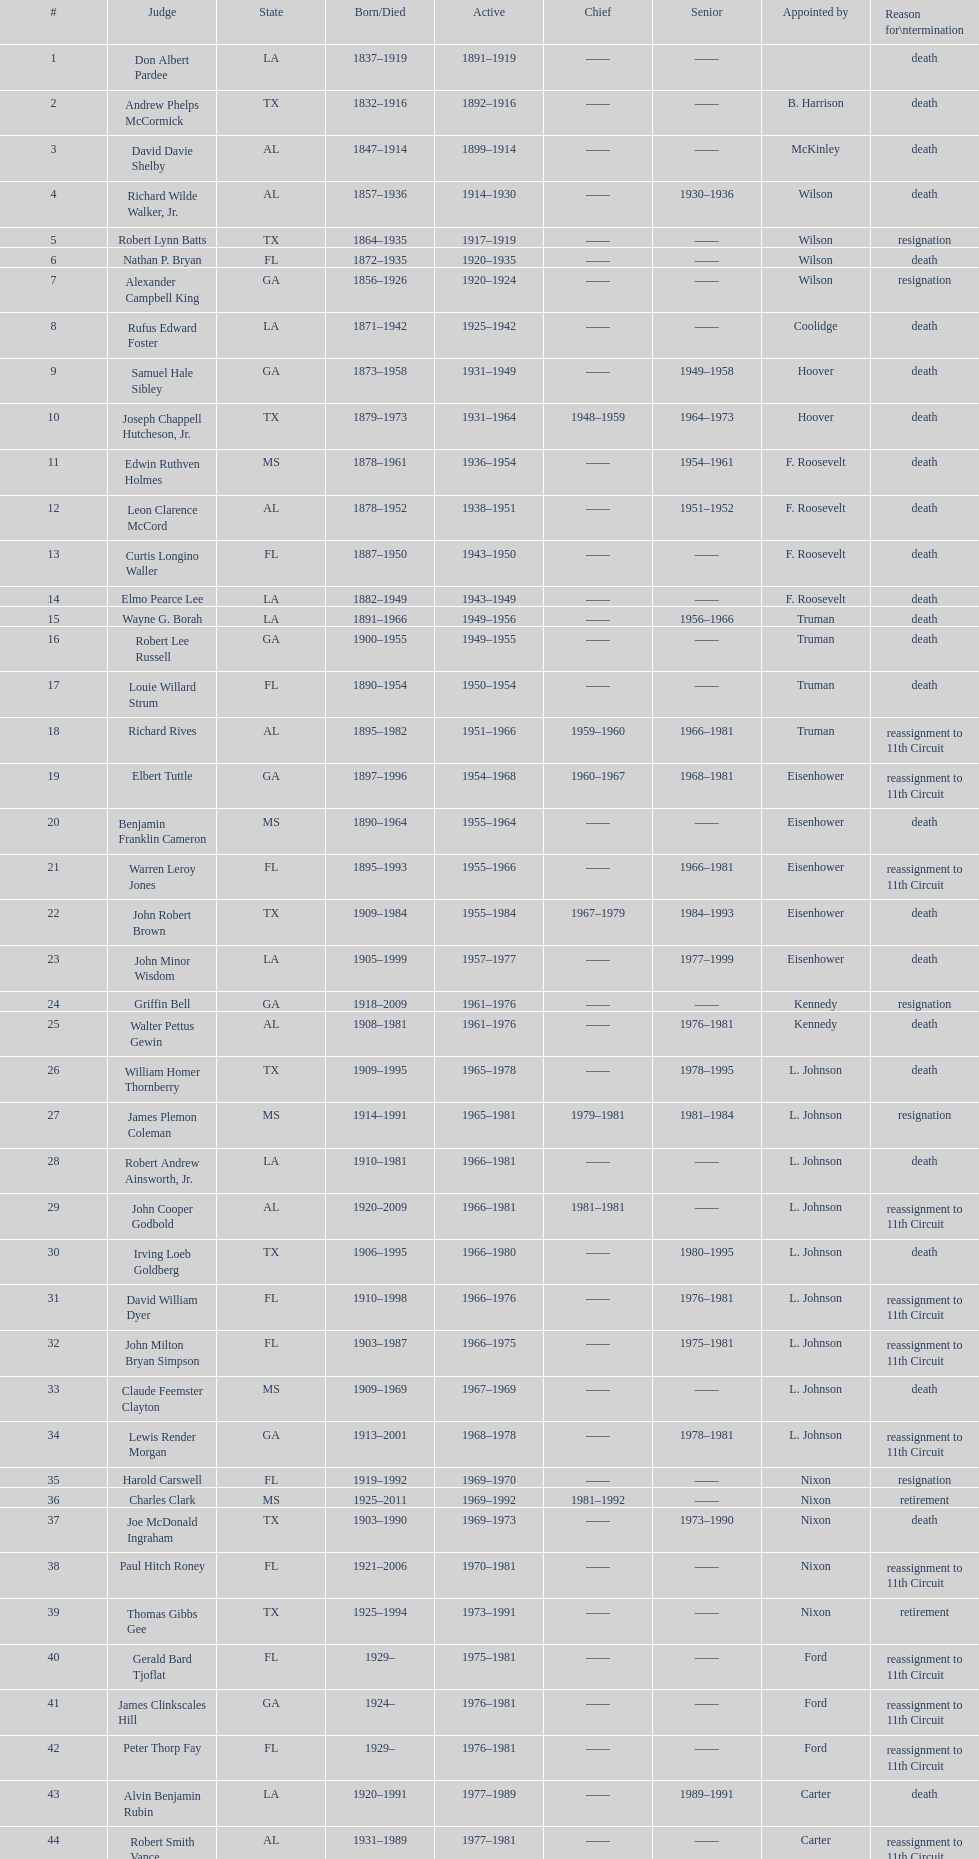After alexander campbell king, which judge resigned next? Griffin Bell. Would you mind parsing the complete table? {'header': ['#', 'Judge', 'State', 'Born/Died', 'Active', 'Chief', 'Senior', 'Appointed by', 'Reason for\\ntermination'], 'rows': [['1', 'Don Albert Pardee', 'LA', '1837–1919', '1891–1919', '——', '——', '', 'death'], ['2', 'Andrew Phelps McCormick', 'TX', '1832–1916', '1892–1916', '——', '——', 'B. Harrison', 'death'], ['3', 'David Davie Shelby', 'AL', '1847–1914', '1899–1914', '——', '——', 'McKinley', 'death'], ['4', 'Richard Wilde Walker, Jr.', 'AL', '1857–1936', '1914–1930', '——', '1930–1936', 'Wilson', 'death'], ['5', 'Robert Lynn Batts', 'TX', '1864–1935', '1917–1919', '——', '——', 'Wilson', 'resignation'], ['6', 'Nathan P. Bryan', 'FL', '1872–1935', '1920–1935', '——', '——', 'Wilson', 'death'], ['7', 'Alexander Campbell King', 'GA', '1856–1926', '1920–1924', '——', '——', 'Wilson', 'resignation'], ['8', 'Rufus Edward Foster', 'LA', '1871–1942', '1925–1942', '——', '——', 'Coolidge', 'death'], ['9', 'Samuel Hale Sibley', 'GA', '1873–1958', '1931–1949', '——', '1949–1958', 'Hoover', 'death'], ['10', 'Joseph Chappell Hutcheson, Jr.', 'TX', '1879–1973', '1931–1964', '1948–1959', '1964–1973', 'Hoover', 'death'], ['11', 'Edwin Ruthven Holmes', 'MS', '1878–1961', '1936–1954', '——', '1954–1961', 'F. Roosevelt', 'death'], ['12', 'Leon Clarence McCord', 'AL', '1878–1952', '1938–1951', '——', '1951–1952', 'F. Roosevelt', 'death'], ['13', 'Curtis Longino Waller', 'FL', '1887–1950', '1943–1950', '——', '——', 'F. Roosevelt', 'death'], ['14', 'Elmo Pearce Lee', 'LA', '1882–1949', '1943–1949', '——', '——', 'F. Roosevelt', 'death'], ['15', 'Wayne G. Borah', 'LA', '1891–1966', '1949–1956', '——', '1956–1966', 'Truman', 'death'], ['16', 'Robert Lee Russell', 'GA', '1900–1955', '1949–1955', '——', '——', 'Truman', 'death'], ['17', 'Louie Willard Strum', 'FL', '1890–1954', '1950–1954', '——', '——', 'Truman', 'death'], ['18', 'Richard Rives', 'AL', '1895–1982', '1951–1966', '1959–1960', '1966–1981', 'Truman', 'reassignment to 11th Circuit'], ['19', 'Elbert Tuttle', 'GA', '1897–1996', '1954–1968', '1960–1967', '1968–1981', 'Eisenhower', 'reassignment to 11th Circuit'], ['20', 'Benjamin Franklin Cameron', 'MS', '1890–1964', '1955–1964', '——', '——', 'Eisenhower', 'death'], ['21', 'Warren Leroy Jones', 'FL', '1895–1993', '1955–1966', '——', '1966–1981', 'Eisenhower', 'reassignment to 11th Circuit'], ['22', 'John Robert Brown', 'TX', '1909–1984', '1955–1984', '1967–1979', '1984–1993', 'Eisenhower', 'death'], ['23', 'John Minor Wisdom', 'LA', '1905–1999', '1957–1977', '——', '1977–1999', 'Eisenhower', 'death'], ['24', 'Griffin Bell', 'GA', '1918–2009', '1961–1976', '——', '——', 'Kennedy', 'resignation'], ['25', 'Walter Pettus Gewin', 'AL', '1908–1981', '1961–1976', '——', '1976–1981', 'Kennedy', 'death'], ['26', 'William Homer Thornberry', 'TX', '1909–1995', '1965–1978', '——', '1978–1995', 'L. Johnson', 'death'], ['27', 'James Plemon Coleman', 'MS', '1914–1991', '1965–1981', '1979–1981', '1981–1984', 'L. Johnson', 'resignation'], ['28', 'Robert Andrew Ainsworth, Jr.', 'LA', '1910–1981', '1966–1981', '——', '——', 'L. Johnson', 'death'], ['29', 'John Cooper Godbold', 'AL', '1920–2009', '1966–1981', '1981–1981', '——', 'L. Johnson', 'reassignment to 11th Circuit'], ['30', 'Irving Loeb Goldberg', 'TX', '1906–1995', '1966–1980', '——', '1980–1995', 'L. Johnson', 'death'], ['31', 'David William Dyer', 'FL', '1910–1998', '1966–1976', '——', '1976–1981', 'L. Johnson', 'reassignment to 11th Circuit'], ['32', 'John Milton Bryan Simpson', 'FL', '1903–1987', '1966–1975', '——', '1975–1981', 'L. Johnson', 'reassignment to 11th Circuit'], ['33', 'Claude Feemster Clayton', 'MS', '1909–1969', '1967–1969', '——', '——', 'L. Johnson', 'death'], ['34', 'Lewis Render Morgan', 'GA', '1913–2001', '1968–1978', '——', '1978–1981', 'L. Johnson', 'reassignment to 11th Circuit'], ['35', 'Harold Carswell', 'FL', '1919–1992', '1969–1970', '——', '——', 'Nixon', 'resignation'], ['36', 'Charles Clark', 'MS', '1925–2011', '1969–1992', '1981–1992', '——', 'Nixon', 'retirement'], ['37', 'Joe McDonald Ingraham', 'TX', '1903–1990', '1969–1973', '——', '1973–1990', 'Nixon', 'death'], ['38', 'Paul Hitch Roney', 'FL', '1921–2006', '1970–1981', '——', '——', 'Nixon', 'reassignment to 11th Circuit'], ['39', 'Thomas Gibbs Gee', 'TX', '1925–1994', '1973–1991', '——', '——', 'Nixon', 'retirement'], ['40', 'Gerald Bard Tjoflat', 'FL', '1929–', '1975–1981', '——', '——', 'Ford', 'reassignment to 11th Circuit'], ['41', 'James Clinkscales Hill', 'GA', '1924–', '1976–1981', '——', '——', 'Ford', 'reassignment to 11th Circuit'], ['42', 'Peter Thorp Fay', 'FL', '1929–', '1976–1981', '——', '——', 'Ford', 'reassignment to 11th Circuit'], ['43', 'Alvin Benjamin Rubin', 'LA', '1920–1991', '1977–1989', '——', '1989–1991', 'Carter', 'death'], ['44', 'Robert Smith Vance', 'AL', '1931–1989', '1977–1981', '——', '——', 'Carter', 'reassignment to 11th Circuit'], ['45', 'Phyllis A. Kravitch', 'GA', '1920–', '1979–1981', '——', '——', 'Carter', 'reassignment to 11th Circuit'], ['46', 'Frank Minis Johnson', 'AL', '1918–1999', '1979–1981', '——', '——', 'Carter', 'reassignment to 11th Circuit'], ['47', 'R. Lanier Anderson III', 'GA', '1936–', '1979–1981', '——', '——', 'Carter', 'reassignment to 11th Circuit'], ['48', 'Reynaldo Guerra Garza', 'TX', '1915–2004', '1979–1982', '——', '1982–2004', 'Carter', 'death'], ['49', 'Joseph Woodrow Hatchett', 'FL', '1932–', '1979–1981', '——', '——', 'Carter', 'reassignment to 11th Circuit'], ['50', 'Albert John Henderson', 'GA', '1920–1999', '1979–1981', '——', '——', 'Carter', 'reassignment to 11th Circuit'], ['52', 'Henry Anthony Politz', 'LA', '1932–2002', '1979–1999', '1992–1999', '1999–2002', 'Carter', 'death'], ['54', 'Samuel D. Johnson, Jr.', 'TX', '1920–2002', '1979–1991', '——', '1991–2002', 'Carter', 'death'], ['55', 'Albert Tate, Jr.', 'LA', '1920–1986', '1979–1986', '——', '——', 'Carter', 'death'], ['56', 'Thomas Alonzo Clark', 'GA', '1920–2005', '1979–1981', '——', '——', 'Carter', 'reassignment to 11th Circuit'], ['57', 'Jerre Stockton Williams', 'TX', '1916–1993', '1980–1990', '——', '1990–1993', 'Carter', 'death'], ['58', 'William Lockhart Garwood', 'TX', '1931–2011', '1981–1997', '——', '1997–2011', 'Reagan', 'death'], ['62', 'Robert Madden Hill', 'TX', '1928–1987', '1984–1987', '——', '——', 'Reagan', 'death'], ['65', 'John Malcolm Duhé, Jr.', 'LA', '1933-', '1988–1999', '——', '1999–2011', 'Reagan', 'retirement'], ['72', 'Robert Manley Parker', 'TX', '1937–', '1994–2002', '——', '——', 'Clinton', 'retirement'], ['76', 'Charles W. Pickering', 'MS', '1937–', '2004–2004', '——', '——', 'G.W. Bush', 'retirement']]} 